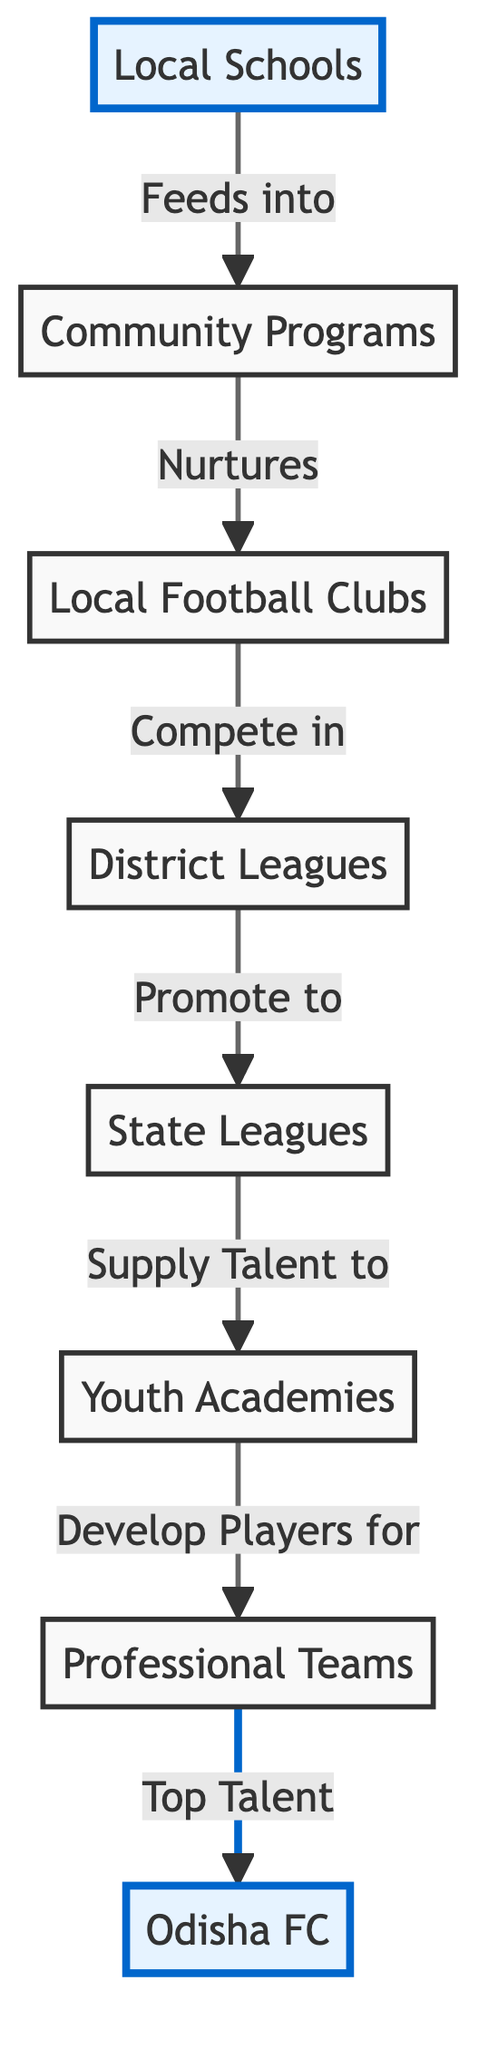What is the first step in the local football ecosystem? The diagram indicates that the first step in the local football ecosystem is "Local Schools," which serve as the entry point for grassroots talent.
Answer: Local Schools How many main entities are there in this local football ecosystem? Counting the boxes in the diagram, there are a total of 8 main entities: Local Schools, Community Programs, Local Football Clubs, District Leagues, State Leagues, Youth Academies, Professional Teams, and Odisha FC.
Answer: 8 Which entity feeds into Community Programs? According to the flowchart, Local Schools are the entity that feeds into Community Programs, highlighting the relationship between grassroots education and local football initiatives.
Answer: Local Schools What role do State Leagues play in this ecosystem? The diagram shows that State Leagues "Supply Talent to" Youth Academies, indicating that State Leagues are crucial in identifying and providing players for further development.
Answer: Supply Talent to Which entity is directly associated with Odisha FC? The final connection in the flowchart shows that Professional Teams, specifically, feed top talent to Odisha FC, making Odisha FC a direct beneficiary of the local football development pipeline.
Answer: Professional Teams Why is the relationship between Local Football Clubs and District Leagues important? Local Football Clubs compete in District Leagues, which is significant as it establishes a competitive environment essential for player development and progression to higher levels of competition.
Answer: Compete in What is the highest level in this local football ecosystem? The diagram indicates that the highest level in the local football ecosystem is "Odisha FC," which represents the top professional team derived from the entire developmental structure.
Answer: Odisha FC How does talent progress from Youth Academies to Professional Teams? The flowchart illustrates that Youth Academies are responsible for developing players, which are then transitioned to Professional Teams, completing the pathway from grassroots to professional level.
Answer: Develop Players for What happens after players compete in District Leagues? The next step after competing in District Leagues is promotion to State Leagues, indicating a pathway for advancing talent based on performance.
Answer: Promote to 